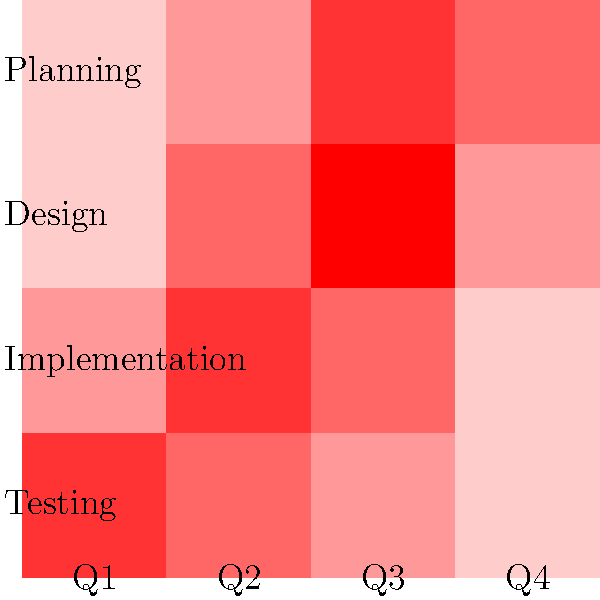Based on the resource allocation heatmap shown, which project phase requires the most attention in Q3, and what strategic planning considerations should be made? To answer this question, we need to analyze the heatmap and interpret its implications for strategic planning:

1. Examine the Q3 column (third from left) in the heatmap.
2. Identify the darkest red cell in this column, which represents the highest resource allocation.
3. The darkest red cell in Q3 corresponds to the "Design" phase.
4. This indicates that the Design phase requires the most resources and attention in Q3.

Strategic planning considerations:

1. Resource allocation: Ensure that sufficient resources (personnel, tools, budget) are available for the Design phase in Q3.
2. Risk management: 
   a. Identify potential bottlenecks or challenges in the Design phase.
   b. Develop contingency plans to address possible delays or issues.
3. Dependencies: 
   a. Evaluate how the high resource demand in Design might impact other phases.
   b. Adjust timelines or resource allocations in other phases if necessary.
4. Skill requirements: Ensure that the team has the necessary skills and expertise for the intense Design work in Q3.
5. Communication: Plan for increased communication and coordination during this critical Design period.
6. Quality assurance: Implement robust quality control measures to ensure that the high-intensity Design work meets project standards.
7. Stakeholder management: Keep stakeholders informed about the focus on Design in Q3 and manage expectations accordingly.

By addressing these strategic planning considerations, the project director can better manage the high resource demand in the Design phase during Q3 and mitigate potential risks to the project's success.
Answer: Design phase; allocate resources, manage risks, address dependencies, ensure skills, increase communication, implement quality control, and manage stakeholder expectations. 